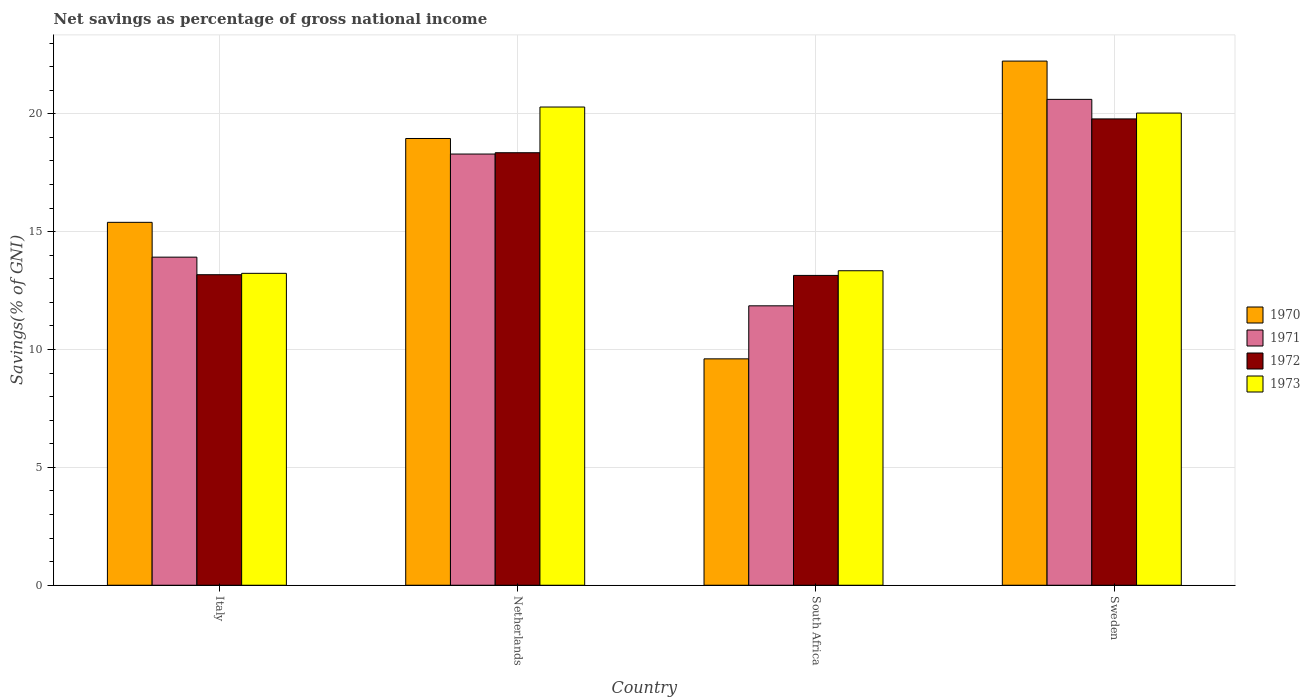How many different coloured bars are there?
Your response must be concise. 4. How many groups of bars are there?
Keep it short and to the point. 4. Are the number of bars per tick equal to the number of legend labels?
Provide a succinct answer. Yes. How many bars are there on the 4th tick from the left?
Ensure brevity in your answer.  4. How many bars are there on the 3rd tick from the right?
Provide a short and direct response. 4. What is the label of the 1st group of bars from the left?
Provide a succinct answer. Italy. What is the total savings in 1971 in South Africa?
Provide a succinct answer. 11.85. Across all countries, what is the maximum total savings in 1972?
Offer a terse response. 19.78. Across all countries, what is the minimum total savings in 1973?
Give a very brief answer. 13.23. In which country was the total savings in 1970 maximum?
Give a very brief answer. Sweden. In which country was the total savings in 1970 minimum?
Make the answer very short. South Africa. What is the total total savings in 1972 in the graph?
Offer a terse response. 64.45. What is the difference between the total savings in 1970 in Italy and that in South Africa?
Offer a terse response. 5.79. What is the difference between the total savings in 1972 in Sweden and the total savings in 1973 in Italy?
Make the answer very short. 6.55. What is the average total savings in 1970 per country?
Give a very brief answer. 16.55. What is the difference between the total savings of/in 1972 and total savings of/in 1970 in Sweden?
Provide a succinct answer. -2.45. In how many countries, is the total savings in 1971 greater than 4 %?
Your response must be concise. 4. What is the ratio of the total savings in 1973 in Netherlands to that in Sweden?
Provide a succinct answer. 1.01. Is the difference between the total savings in 1972 in Netherlands and South Africa greater than the difference between the total savings in 1970 in Netherlands and South Africa?
Your response must be concise. No. What is the difference between the highest and the second highest total savings in 1973?
Ensure brevity in your answer.  -6.95. What is the difference between the highest and the lowest total savings in 1972?
Your response must be concise. 6.64. In how many countries, is the total savings in 1971 greater than the average total savings in 1971 taken over all countries?
Offer a terse response. 2. What does the 2nd bar from the right in Sweden represents?
Provide a short and direct response. 1972. Is it the case that in every country, the sum of the total savings in 1972 and total savings in 1970 is greater than the total savings in 1971?
Your response must be concise. Yes. Are the values on the major ticks of Y-axis written in scientific E-notation?
Your response must be concise. No. Does the graph contain any zero values?
Offer a very short reply. No. What is the title of the graph?
Make the answer very short. Net savings as percentage of gross national income. What is the label or title of the Y-axis?
Provide a succinct answer. Savings(% of GNI). What is the Savings(% of GNI) in 1970 in Italy?
Give a very brief answer. 15.4. What is the Savings(% of GNI) in 1971 in Italy?
Offer a very short reply. 13.92. What is the Savings(% of GNI) of 1972 in Italy?
Provide a short and direct response. 13.17. What is the Savings(% of GNI) of 1973 in Italy?
Keep it short and to the point. 13.23. What is the Savings(% of GNI) in 1970 in Netherlands?
Provide a short and direct response. 18.95. What is the Savings(% of GNI) in 1971 in Netherlands?
Your answer should be compact. 18.29. What is the Savings(% of GNI) in 1972 in Netherlands?
Give a very brief answer. 18.35. What is the Savings(% of GNI) in 1973 in Netherlands?
Your response must be concise. 20.29. What is the Savings(% of GNI) of 1970 in South Africa?
Provide a short and direct response. 9.6. What is the Savings(% of GNI) of 1971 in South Africa?
Offer a very short reply. 11.85. What is the Savings(% of GNI) of 1972 in South Africa?
Ensure brevity in your answer.  13.14. What is the Savings(% of GNI) in 1973 in South Africa?
Give a very brief answer. 13.34. What is the Savings(% of GNI) in 1970 in Sweden?
Give a very brief answer. 22.24. What is the Savings(% of GNI) in 1971 in Sweden?
Give a very brief answer. 20.61. What is the Savings(% of GNI) in 1972 in Sweden?
Offer a terse response. 19.78. What is the Savings(% of GNI) of 1973 in Sweden?
Your answer should be very brief. 20.03. Across all countries, what is the maximum Savings(% of GNI) of 1970?
Keep it short and to the point. 22.24. Across all countries, what is the maximum Savings(% of GNI) of 1971?
Your response must be concise. 20.61. Across all countries, what is the maximum Savings(% of GNI) of 1972?
Your response must be concise. 19.78. Across all countries, what is the maximum Savings(% of GNI) in 1973?
Make the answer very short. 20.29. Across all countries, what is the minimum Savings(% of GNI) in 1970?
Provide a succinct answer. 9.6. Across all countries, what is the minimum Savings(% of GNI) in 1971?
Keep it short and to the point. 11.85. Across all countries, what is the minimum Savings(% of GNI) in 1972?
Give a very brief answer. 13.14. Across all countries, what is the minimum Savings(% of GNI) in 1973?
Provide a short and direct response. 13.23. What is the total Savings(% of GNI) of 1970 in the graph?
Provide a succinct answer. 66.19. What is the total Savings(% of GNI) in 1971 in the graph?
Provide a succinct answer. 64.68. What is the total Savings(% of GNI) of 1972 in the graph?
Ensure brevity in your answer.  64.45. What is the total Savings(% of GNI) in 1973 in the graph?
Offer a terse response. 66.89. What is the difference between the Savings(% of GNI) in 1970 in Italy and that in Netherlands?
Offer a terse response. -3.56. What is the difference between the Savings(% of GNI) in 1971 in Italy and that in Netherlands?
Provide a succinct answer. -4.37. What is the difference between the Savings(% of GNI) in 1972 in Italy and that in Netherlands?
Provide a succinct answer. -5.18. What is the difference between the Savings(% of GNI) of 1973 in Italy and that in Netherlands?
Make the answer very short. -7.06. What is the difference between the Savings(% of GNI) in 1970 in Italy and that in South Africa?
Offer a very short reply. 5.79. What is the difference between the Savings(% of GNI) of 1971 in Italy and that in South Africa?
Make the answer very short. 2.07. What is the difference between the Savings(% of GNI) of 1972 in Italy and that in South Africa?
Offer a very short reply. 0.03. What is the difference between the Savings(% of GNI) of 1973 in Italy and that in South Africa?
Provide a succinct answer. -0.11. What is the difference between the Savings(% of GNI) of 1970 in Italy and that in Sweden?
Ensure brevity in your answer.  -6.84. What is the difference between the Savings(% of GNI) of 1971 in Italy and that in Sweden?
Your response must be concise. -6.69. What is the difference between the Savings(% of GNI) of 1972 in Italy and that in Sweden?
Your response must be concise. -6.61. What is the difference between the Savings(% of GNI) in 1973 in Italy and that in Sweden?
Offer a very short reply. -6.8. What is the difference between the Savings(% of GNI) in 1970 in Netherlands and that in South Africa?
Provide a short and direct response. 9.35. What is the difference between the Savings(% of GNI) of 1971 in Netherlands and that in South Africa?
Give a very brief answer. 6.44. What is the difference between the Savings(% of GNI) of 1972 in Netherlands and that in South Africa?
Keep it short and to the point. 5.21. What is the difference between the Savings(% of GNI) in 1973 in Netherlands and that in South Africa?
Offer a very short reply. 6.95. What is the difference between the Savings(% of GNI) of 1970 in Netherlands and that in Sweden?
Your answer should be compact. -3.28. What is the difference between the Savings(% of GNI) in 1971 in Netherlands and that in Sweden?
Provide a succinct answer. -2.32. What is the difference between the Savings(% of GNI) of 1972 in Netherlands and that in Sweden?
Give a very brief answer. -1.43. What is the difference between the Savings(% of GNI) in 1973 in Netherlands and that in Sweden?
Give a very brief answer. 0.26. What is the difference between the Savings(% of GNI) of 1970 in South Africa and that in Sweden?
Ensure brevity in your answer.  -12.63. What is the difference between the Savings(% of GNI) of 1971 in South Africa and that in Sweden?
Give a very brief answer. -8.76. What is the difference between the Savings(% of GNI) of 1972 in South Africa and that in Sweden?
Offer a terse response. -6.64. What is the difference between the Savings(% of GNI) in 1973 in South Africa and that in Sweden?
Provide a short and direct response. -6.69. What is the difference between the Savings(% of GNI) in 1970 in Italy and the Savings(% of GNI) in 1971 in Netherlands?
Keep it short and to the point. -2.9. What is the difference between the Savings(% of GNI) in 1970 in Italy and the Savings(% of GNI) in 1972 in Netherlands?
Your answer should be compact. -2.95. What is the difference between the Savings(% of GNI) in 1970 in Italy and the Savings(% of GNI) in 1973 in Netherlands?
Offer a terse response. -4.89. What is the difference between the Savings(% of GNI) in 1971 in Italy and the Savings(% of GNI) in 1972 in Netherlands?
Make the answer very short. -4.43. What is the difference between the Savings(% of GNI) in 1971 in Italy and the Savings(% of GNI) in 1973 in Netherlands?
Offer a very short reply. -6.37. What is the difference between the Savings(% of GNI) in 1972 in Italy and the Savings(% of GNI) in 1973 in Netherlands?
Offer a very short reply. -7.11. What is the difference between the Savings(% of GNI) in 1970 in Italy and the Savings(% of GNI) in 1971 in South Africa?
Provide a succinct answer. 3.54. What is the difference between the Savings(% of GNI) in 1970 in Italy and the Savings(% of GNI) in 1972 in South Africa?
Offer a very short reply. 2.25. What is the difference between the Savings(% of GNI) in 1970 in Italy and the Savings(% of GNI) in 1973 in South Africa?
Provide a succinct answer. 2.05. What is the difference between the Savings(% of GNI) in 1971 in Italy and the Savings(% of GNI) in 1972 in South Africa?
Your answer should be compact. 0.78. What is the difference between the Savings(% of GNI) in 1971 in Italy and the Savings(% of GNI) in 1973 in South Africa?
Make the answer very short. 0.58. What is the difference between the Savings(% of GNI) in 1972 in Italy and the Savings(% of GNI) in 1973 in South Africa?
Give a very brief answer. -0.17. What is the difference between the Savings(% of GNI) of 1970 in Italy and the Savings(% of GNI) of 1971 in Sweden?
Provide a succinct answer. -5.22. What is the difference between the Savings(% of GNI) in 1970 in Italy and the Savings(% of GNI) in 1972 in Sweden?
Make the answer very short. -4.39. What is the difference between the Savings(% of GNI) in 1970 in Italy and the Savings(% of GNI) in 1973 in Sweden?
Your answer should be compact. -4.64. What is the difference between the Savings(% of GNI) in 1971 in Italy and the Savings(% of GNI) in 1972 in Sweden?
Offer a terse response. -5.86. What is the difference between the Savings(% of GNI) in 1971 in Italy and the Savings(% of GNI) in 1973 in Sweden?
Ensure brevity in your answer.  -6.11. What is the difference between the Savings(% of GNI) of 1972 in Italy and the Savings(% of GNI) of 1973 in Sweden?
Make the answer very short. -6.86. What is the difference between the Savings(% of GNI) in 1970 in Netherlands and the Savings(% of GNI) in 1971 in South Africa?
Offer a terse response. 7.1. What is the difference between the Savings(% of GNI) of 1970 in Netherlands and the Savings(% of GNI) of 1972 in South Africa?
Offer a terse response. 5.81. What is the difference between the Savings(% of GNI) in 1970 in Netherlands and the Savings(% of GNI) in 1973 in South Africa?
Make the answer very short. 5.61. What is the difference between the Savings(% of GNI) in 1971 in Netherlands and the Savings(% of GNI) in 1972 in South Africa?
Give a very brief answer. 5.15. What is the difference between the Savings(% of GNI) of 1971 in Netherlands and the Savings(% of GNI) of 1973 in South Africa?
Your answer should be compact. 4.95. What is the difference between the Savings(% of GNI) in 1972 in Netherlands and the Savings(% of GNI) in 1973 in South Africa?
Keep it short and to the point. 5.01. What is the difference between the Savings(% of GNI) of 1970 in Netherlands and the Savings(% of GNI) of 1971 in Sweden?
Provide a succinct answer. -1.66. What is the difference between the Savings(% of GNI) of 1970 in Netherlands and the Savings(% of GNI) of 1972 in Sweden?
Ensure brevity in your answer.  -0.83. What is the difference between the Savings(% of GNI) of 1970 in Netherlands and the Savings(% of GNI) of 1973 in Sweden?
Provide a short and direct response. -1.08. What is the difference between the Savings(% of GNI) of 1971 in Netherlands and the Savings(% of GNI) of 1972 in Sweden?
Provide a succinct answer. -1.49. What is the difference between the Savings(% of GNI) in 1971 in Netherlands and the Savings(% of GNI) in 1973 in Sweden?
Offer a terse response. -1.74. What is the difference between the Savings(% of GNI) in 1972 in Netherlands and the Savings(% of GNI) in 1973 in Sweden?
Make the answer very short. -1.68. What is the difference between the Savings(% of GNI) in 1970 in South Africa and the Savings(% of GNI) in 1971 in Sweden?
Ensure brevity in your answer.  -11.01. What is the difference between the Savings(% of GNI) in 1970 in South Africa and the Savings(% of GNI) in 1972 in Sweden?
Offer a terse response. -10.18. What is the difference between the Savings(% of GNI) of 1970 in South Africa and the Savings(% of GNI) of 1973 in Sweden?
Keep it short and to the point. -10.43. What is the difference between the Savings(% of GNI) in 1971 in South Africa and the Savings(% of GNI) in 1972 in Sweden?
Make the answer very short. -7.93. What is the difference between the Savings(% of GNI) in 1971 in South Africa and the Savings(% of GNI) in 1973 in Sweden?
Ensure brevity in your answer.  -8.18. What is the difference between the Savings(% of GNI) of 1972 in South Africa and the Savings(% of GNI) of 1973 in Sweden?
Give a very brief answer. -6.89. What is the average Savings(% of GNI) in 1970 per country?
Keep it short and to the point. 16.55. What is the average Savings(% of GNI) in 1971 per country?
Give a very brief answer. 16.17. What is the average Savings(% of GNI) in 1972 per country?
Your response must be concise. 16.11. What is the average Savings(% of GNI) of 1973 per country?
Your answer should be very brief. 16.72. What is the difference between the Savings(% of GNI) of 1970 and Savings(% of GNI) of 1971 in Italy?
Keep it short and to the point. 1.48. What is the difference between the Savings(% of GNI) in 1970 and Savings(% of GNI) in 1972 in Italy?
Ensure brevity in your answer.  2.22. What is the difference between the Savings(% of GNI) in 1970 and Savings(% of GNI) in 1973 in Italy?
Offer a very short reply. 2.16. What is the difference between the Savings(% of GNI) in 1971 and Savings(% of GNI) in 1972 in Italy?
Offer a terse response. 0.75. What is the difference between the Savings(% of GNI) in 1971 and Savings(% of GNI) in 1973 in Italy?
Your answer should be very brief. 0.69. What is the difference between the Savings(% of GNI) of 1972 and Savings(% of GNI) of 1973 in Italy?
Make the answer very short. -0.06. What is the difference between the Savings(% of GNI) of 1970 and Savings(% of GNI) of 1971 in Netherlands?
Provide a succinct answer. 0.66. What is the difference between the Savings(% of GNI) of 1970 and Savings(% of GNI) of 1972 in Netherlands?
Your response must be concise. 0.6. What is the difference between the Savings(% of GNI) in 1970 and Savings(% of GNI) in 1973 in Netherlands?
Your response must be concise. -1.33. What is the difference between the Savings(% of GNI) of 1971 and Savings(% of GNI) of 1972 in Netherlands?
Provide a short and direct response. -0.06. What is the difference between the Savings(% of GNI) in 1971 and Savings(% of GNI) in 1973 in Netherlands?
Your answer should be compact. -1.99. What is the difference between the Savings(% of GNI) in 1972 and Savings(% of GNI) in 1973 in Netherlands?
Provide a succinct answer. -1.94. What is the difference between the Savings(% of GNI) of 1970 and Savings(% of GNI) of 1971 in South Africa?
Provide a short and direct response. -2.25. What is the difference between the Savings(% of GNI) in 1970 and Savings(% of GNI) in 1972 in South Africa?
Offer a terse response. -3.54. What is the difference between the Savings(% of GNI) of 1970 and Savings(% of GNI) of 1973 in South Africa?
Your answer should be very brief. -3.74. What is the difference between the Savings(% of GNI) of 1971 and Savings(% of GNI) of 1972 in South Africa?
Your answer should be compact. -1.29. What is the difference between the Savings(% of GNI) of 1971 and Savings(% of GNI) of 1973 in South Africa?
Offer a terse response. -1.49. What is the difference between the Savings(% of GNI) of 1972 and Savings(% of GNI) of 1973 in South Africa?
Keep it short and to the point. -0.2. What is the difference between the Savings(% of GNI) in 1970 and Savings(% of GNI) in 1971 in Sweden?
Provide a succinct answer. 1.62. What is the difference between the Savings(% of GNI) of 1970 and Savings(% of GNI) of 1972 in Sweden?
Make the answer very short. 2.45. What is the difference between the Savings(% of GNI) of 1970 and Savings(% of GNI) of 1973 in Sweden?
Ensure brevity in your answer.  2.21. What is the difference between the Savings(% of GNI) of 1971 and Savings(% of GNI) of 1972 in Sweden?
Ensure brevity in your answer.  0.83. What is the difference between the Savings(% of GNI) of 1971 and Savings(% of GNI) of 1973 in Sweden?
Provide a short and direct response. 0.58. What is the difference between the Savings(% of GNI) in 1972 and Savings(% of GNI) in 1973 in Sweden?
Offer a very short reply. -0.25. What is the ratio of the Savings(% of GNI) in 1970 in Italy to that in Netherlands?
Give a very brief answer. 0.81. What is the ratio of the Savings(% of GNI) of 1971 in Italy to that in Netherlands?
Offer a very short reply. 0.76. What is the ratio of the Savings(% of GNI) of 1972 in Italy to that in Netherlands?
Your answer should be very brief. 0.72. What is the ratio of the Savings(% of GNI) in 1973 in Italy to that in Netherlands?
Give a very brief answer. 0.65. What is the ratio of the Savings(% of GNI) in 1970 in Italy to that in South Africa?
Your answer should be compact. 1.6. What is the ratio of the Savings(% of GNI) of 1971 in Italy to that in South Africa?
Offer a terse response. 1.17. What is the ratio of the Savings(% of GNI) of 1972 in Italy to that in South Africa?
Provide a succinct answer. 1. What is the ratio of the Savings(% of GNI) of 1973 in Italy to that in South Africa?
Offer a terse response. 0.99. What is the ratio of the Savings(% of GNI) in 1970 in Italy to that in Sweden?
Give a very brief answer. 0.69. What is the ratio of the Savings(% of GNI) of 1971 in Italy to that in Sweden?
Your answer should be compact. 0.68. What is the ratio of the Savings(% of GNI) of 1972 in Italy to that in Sweden?
Offer a very short reply. 0.67. What is the ratio of the Savings(% of GNI) in 1973 in Italy to that in Sweden?
Provide a succinct answer. 0.66. What is the ratio of the Savings(% of GNI) in 1970 in Netherlands to that in South Africa?
Keep it short and to the point. 1.97. What is the ratio of the Savings(% of GNI) of 1971 in Netherlands to that in South Africa?
Make the answer very short. 1.54. What is the ratio of the Savings(% of GNI) of 1972 in Netherlands to that in South Africa?
Your answer should be very brief. 1.4. What is the ratio of the Savings(% of GNI) of 1973 in Netherlands to that in South Africa?
Give a very brief answer. 1.52. What is the ratio of the Savings(% of GNI) in 1970 in Netherlands to that in Sweden?
Offer a terse response. 0.85. What is the ratio of the Savings(% of GNI) in 1971 in Netherlands to that in Sweden?
Make the answer very short. 0.89. What is the ratio of the Savings(% of GNI) in 1972 in Netherlands to that in Sweden?
Keep it short and to the point. 0.93. What is the ratio of the Savings(% of GNI) in 1973 in Netherlands to that in Sweden?
Provide a succinct answer. 1.01. What is the ratio of the Savings(% of GNI) of 1970 in South Africa to that in Sweden?
Your response must be concise. 0.43. What is the ratio of the Savings(% of GNI) of 1971 in South Africa to that in Sweden?
Provide a short and direct response. 0.58. What is the ratio of the Savings(% of GNI) of 1972 in South Africa to that in Sweden?
Offer a very short reply. 0.66. What is the ratio of the Savings(% of GNI) in 1973 in South Africa to that in Sweden?
Your answer should be very brief. 0.67. What is the difference between the highest and the second highest Savings(% of GNI) in 1970?
Provide a succinct answer. 3.28. What is the difference between the highest and the second highest Savings(% of GNI) of 1971?
Make the answer very short. 2.32. What is the difference between the highest and the second highest Savings(% of GNI) of 1972?
Provide a succinct answer. 1.43. What is the difference between the highest and the second highest Savings(% of GNI) in 1973?
Your answer should be very brief. 0.26. What is the difference between the highest and the lowest Savings(% of GNI) in 1970?
Provide a short and direct response. 12.63. What is the difference between the highest and the lowest Savings(% of GNI) of 1971?
Keep it short and to the point. 8.76. What is the difference between the highest and the lowest Savings(% of GNI) of 1972?
Your answer should be compact. 6.64. What is the difference between the highest and the lowest Savings(% of GNI) of 1973?
Your response must be concise. 7.06. 